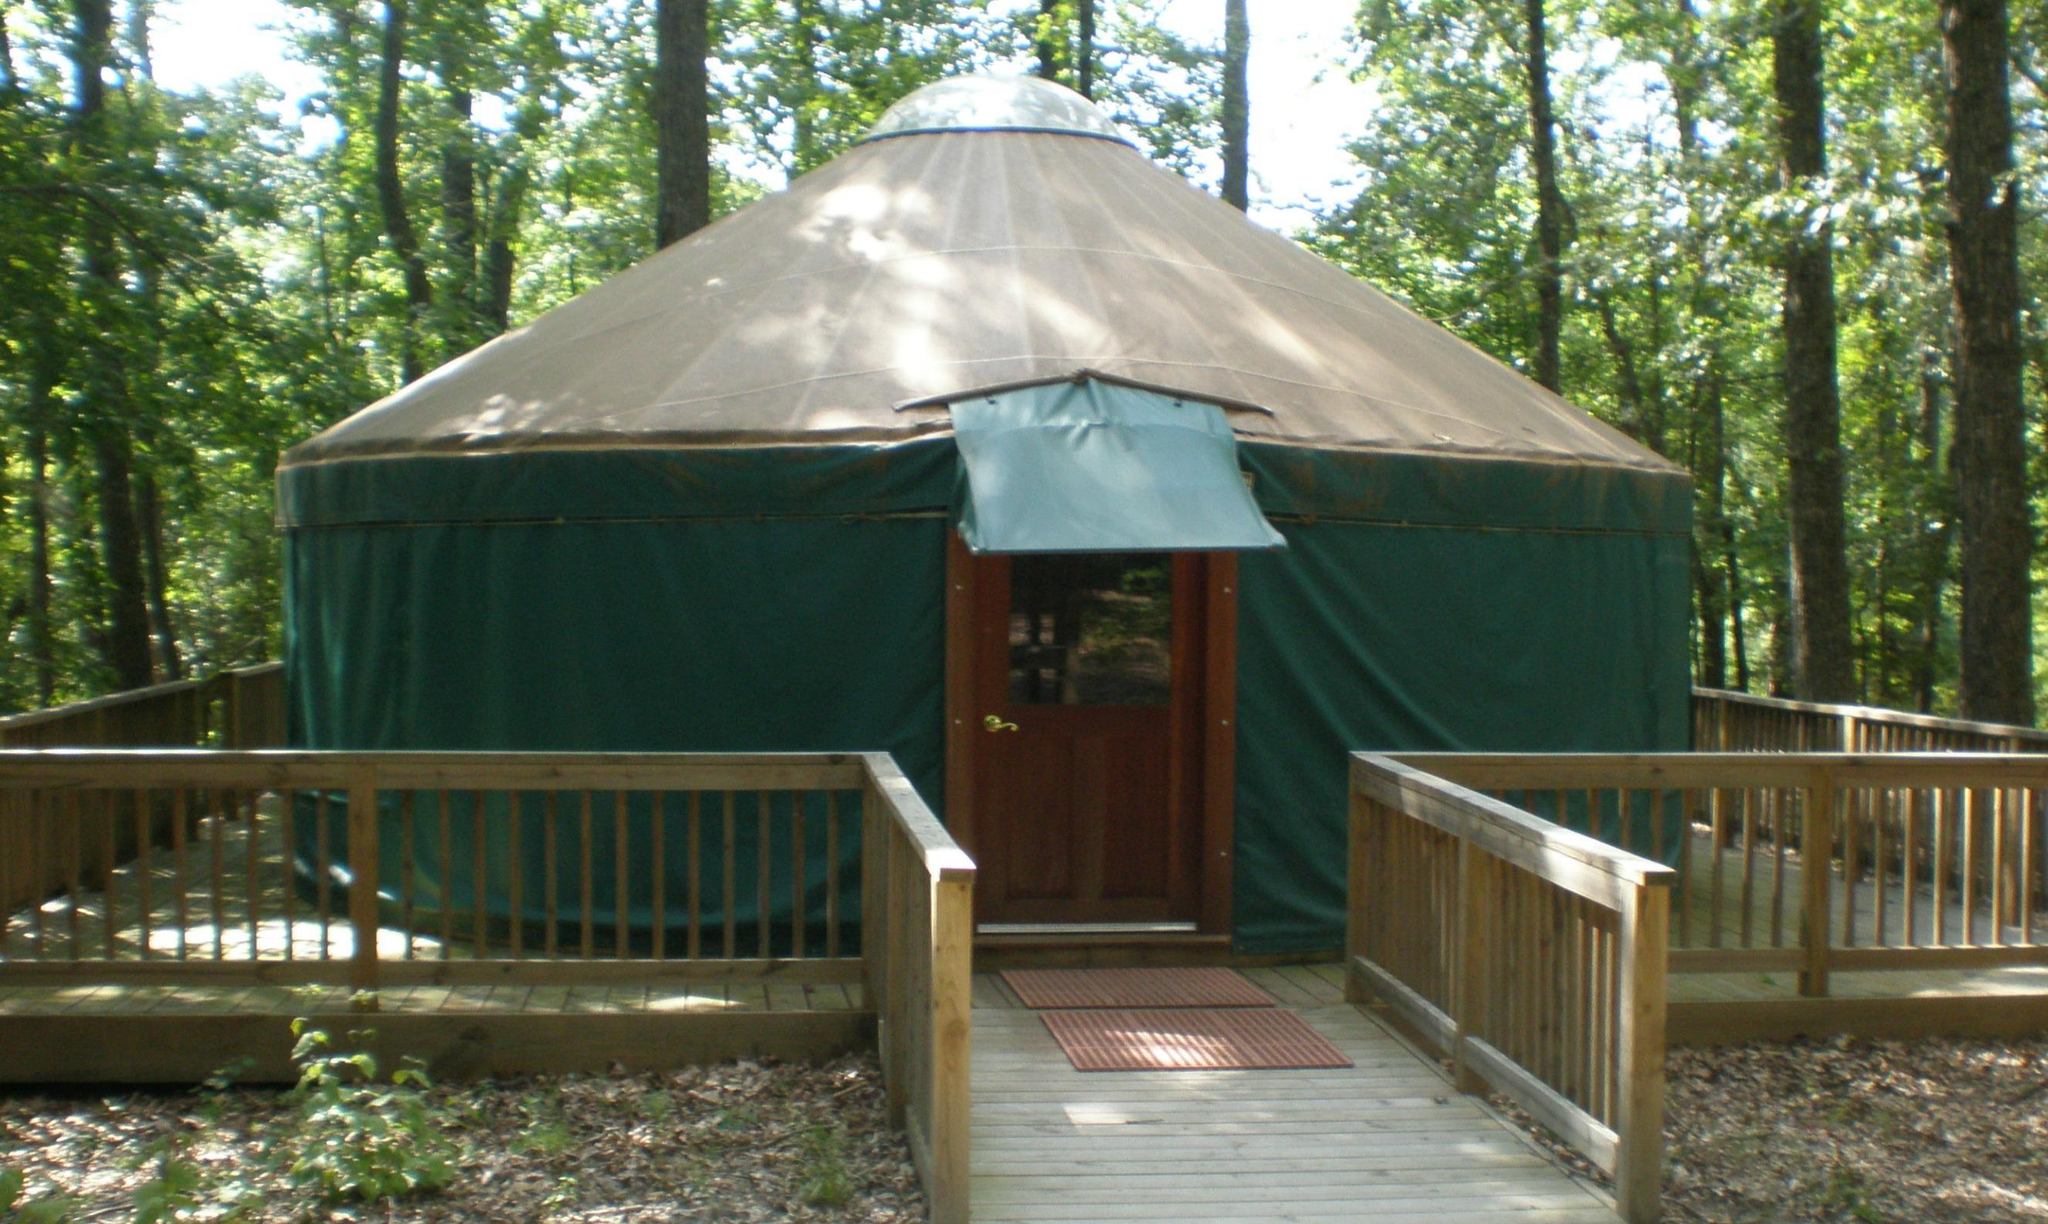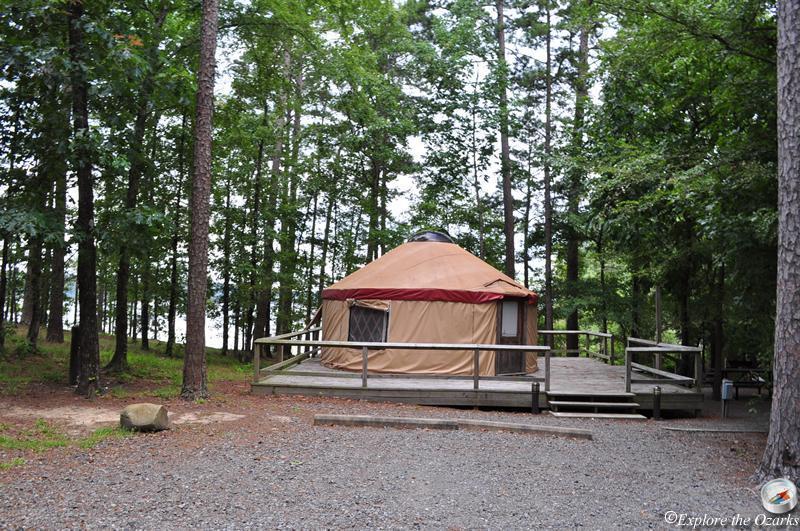The first image is the image on the left, the second image is the image on the right. Considering the images on both sides, is "Multiple lawn chairs are on the ground in front of a round building with a cone-shaped roof." valid? Answer yes or no. No. The first image is the image on the left, the second image is the image on the right. Evaluate the accuracy of this statement regarding the images: "An image shows a green yurt with a pale roof, and it is surrounded by a square railed deck.". Is it true? Answer yes or no. Yes. The first image is the image on the left, the second image is the image on the right. Analyze the images presented: Is the assertion "Two yurts are situated in a woody area on square wooden decks with railings, one of them dark green and the other a different color." valid? Answer yes or no. Yes. The first image is the image on the left, the second image is the image on the right. For the images shown, is this caption "The left image contains a cottage surrounded by a wooden railing." true? Answer yes or no. Yes. 